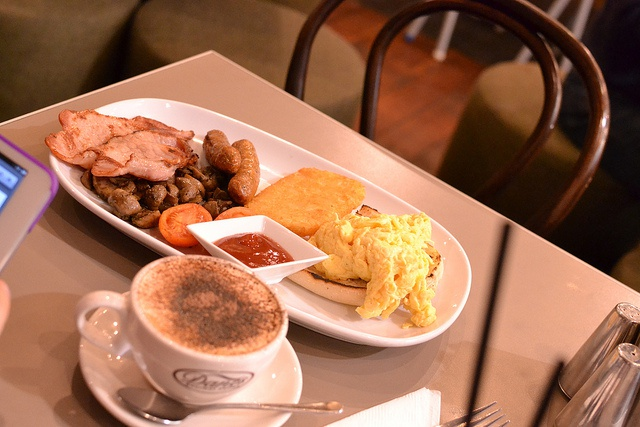Describe the objects in this image and their specific colors. I can see dining table in brown, tan, salmon, and white tones, cup in maroon, salmon, tan, and brown tones, chair in brown, black, and maroon tones, bowl in brown, white, lightpink, and pink tones, and cell phone in brown, salmon, purple, and blue tones in this image. 